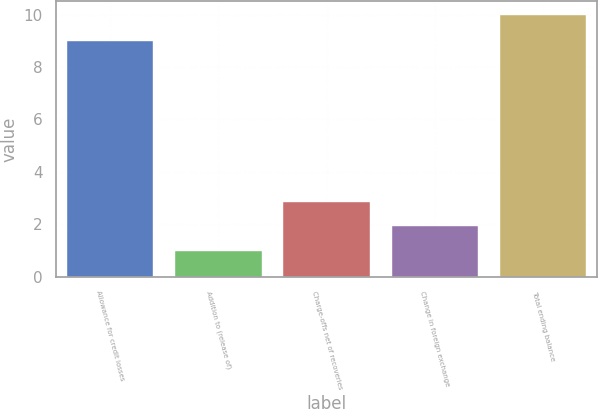Convert chart to OTSL. <chart><loc_0><loc_0><loc_500><loc_500><bar_chart><fcel>Allowance for credit losses<fcel>Addition to (release of)<fcel>Charge-offs net of recoveries<fcel>Change in foreign exchange<fcel>Total ending balance<nl><fcel>9<fcel>1<fcel>2.85<fcel>1.95<fcel>10<nl></chart> 